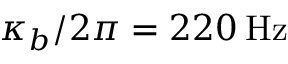Convert formula to latex. <formula><loc_0><loc_0><loc_500><loc_500>\kappa _ { b } / 2 \pi = 2 2 0 \, H z</formula> 